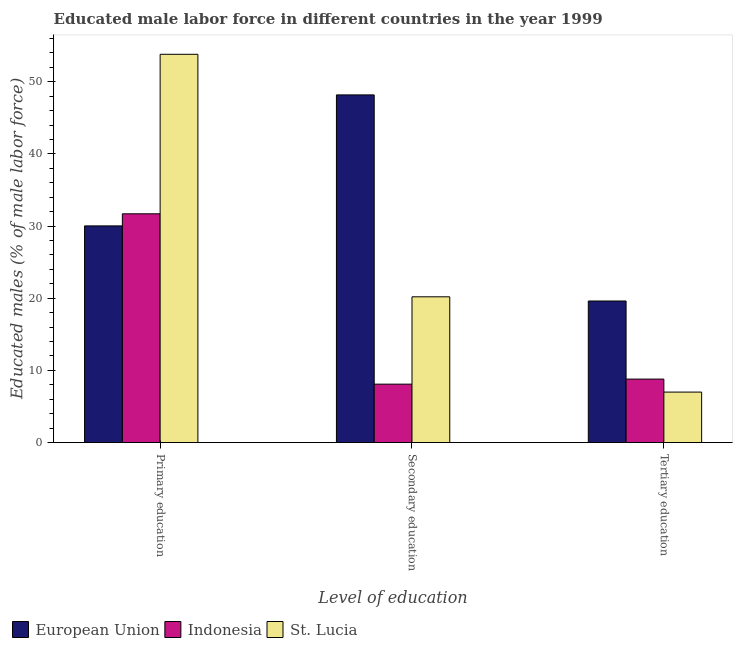How many different coloured bars are there?
Provide a short and direct response. 3. How many groups of bars are there?
Offer a very short reply. 3. Are the number of bars per tick equal to the number of legend labels?
Offer a very short reply. Yes. Are the number of bars on each tick of the X-axis equal?
Give a very brief answer. Yes. What is the label of the 2nd group of bars from the left?
Offer a very short reply. Secondary education. What is the percentage of male labor force who received primary education in European Union?
Keep it short and to the point. 30.02. Across all countries, what is the maximum percentage of male labor force who received secondary education?
Offer a terse response. 48.17. In which country was the percentage of male labor force who received primary education maximum?
Ensure brevity in your answer.  St. Lucia. In which country was the percentage of male labor force who received tertiary education minimum?
Give a very brief answer. St. Lucia. What is the total percentage of male labor force who received tertiary education in the graph?
Make the answer very short. 35.42. What is the difference between the percentage of male labor force who received tertiary education in European Union and that in Indonesia?
Give a very brief answer. 10.82. What is the difference between the percentage of male labor force who received tertiary education in St. Lucia and the percentage of male labor force who received secondary education in European Union?
Make the answer very short. -41.17. What is the average percentage of male labor force who received primary education per country?
Offer a very short reply. 38.51. What is the difference between the percentage of male labor force who received tertiary education and percentage of male labor force who received secondary education in European Union?
Your answer should be compact. -28.55. What is the ratio of the percentage of male labor force who received secondary education in Indonesia to that in European Union?
Provide a short and direct response. 0.17. What is the difference between the highest and the second highest percentage of male labor force who received secondary education?
Offer a very short reply. 27.97. What is the difference between the highest and the lowest percentage of male labor force who received secondary education?
Your response must be concise. 40.07. Is it the case that in every country, the sum of the percentage of male labor force who received primary education and percentage of male labor force who received secondary education is greater than the percentage of male labor force who received tertiary education?
Provide a short and direct response. Yes. Are all the bars in the graph horizontal?
Keep it short and to the point. No. How many countries are there in the graph?
Your response must be concise. 3. What is the difference between two consecutive major ticks on the Y-axis?
Provide a succinct answer. 10. How many legend labels are there?
Your answer should be very brief. 3. What is the title of the graph?
Your response must be concise. Educated male labor force in different countries in the year 1999. Does "Kyrgyz Republic" appear as one of the legend labels in the graph?
Provide a succinct answer. No. What is the label or title of the X-axis?
Your answer should be compact. Level of education. What is the label or title of the Y-axis?
Ensure brevity in your answer.  Educated males (% of male labor force). What is the Educated males (% of male labor force) of European Union in Primary education?
Ensure brevity in your answer.  30.02. What is the Educated males (% of male labor force) of Indonesia in Primary education?
Keep it short and to the point. 31.7. What is the Educated males (% of male labor force) in St. Lucia in Primary education?
Offer a terse response. 53.8. What is the Educated males (% of male labor force) in European Union in Secondary education?
Your answer should be very brief. 48.17. What is the Educated males (% of male labor force) of Indonesia in Secondary education?
Offer a very short reply. 8.1. What is the Educated males (% of male labor force) of St. Lucia in Secondary education?
Offer a terse response. 20.2. What is the Educated males (% of male labor force) in European Union in Tertiary education?
Ensure brevity in your answer.  19.62. What is the Educated males (% of male labor force) in Indonesia in Tertiary education?
Your answer should be very brief. 8.8. Across all Level of education, what is the maximum Educated males (% of male labor force) in European Union?
Offer a terse response. 48.17. Across all Level of education, what is the maximum Educated males (% of male labor force) of Indonesia?
Your answer should be very brief. 31.7. Across all Level of education, what is the maximum Educated males (% of male labor force) in St. Lucia?
Ensure brevity in your answer.  53.8. Across all Level of education, what is the minimum Educated males (% of male labor force) in European Union?
Ensure brevity in your answer.  19.62. Across all Level of education, what is the minimum Educated males (% of male labor force) of Indonesia?
Provide a succinct answer. 8.1. What is the total Educated males (% of male labor force) of European Union in the graph?
Your answer should be very brief. 97.82. What is the total Educated males (% of male labor force) in Indonesia in the graph?
Your answer should be very brief. 48.6. What is the difference between the Educated males (% of male labor force) of European Union in Primary education and that in Secondary education?
Give a very brief answer. -18.15. What is the difference between the Educated males (% of male labor force) in Indonesia in Primary education and that in Secondary education?
Keep it short and to the point. 23.6. What is the difference between the Educated males (% of male labor force) of St. Lucia in Primary education and that in Secondary education?
Ensure brevity in your answer.  33.6. What is the difference between the Educated males (% of male labor force) of European Union in Primary education and that in Tertiary education?
Provide a short and direct response. 10.41. What is the difference between the Educated males (% of male labor force) in Indonesia in Primary education and that in Tertiary education?
Offer a terse response. 22.9. What is the difference between the Educated males (% of male labor force) of St. Lucia in Primary education and that in Tertiary education?
Ensure brevity in your answer.  46.8. What is the difference between the Educated males (% of male labor force) in European Union in Secondary education and that in Tertiary education?
Offer a very short reply. 28.55. What is the difference between the Educated males (% of male labor force) in Indonesia in Secondary education and that in Tertiary education?
Your answer should be very brief. -0.7. What is the difference between the Educated males (% of male labor force) in European Union in Primary education and the Educated males (% of male labor force) in Indonesia in Secondary education?
Give a very brief answer. 21.92. What is the difference between the Educated males (% of male labor force) in European Union in Primary education and the Educated males (% of male labor force) in St. Lucia in Secondary education?
Give a very brief answer. 9.82. What is the difference between the Educated males (% of male labor force) of Indonesia in Primary education and the Educated males (% of male labor force) of St. Lucia in Secondary education?
Make the answer very short. 11.5. What is the difference between the Educated males (% of male labor force) of European Union in Primary education and the Educated males (% of male labor force) of Indonesia in Tertiary education?
Provide a short and direct response. 21.22. What is the difference between the Educated males (% of male labor force) of European Union in Primary education and the Educated males (% of male labor force) of St. Lucia in Tertiary education?
Your answer should be compact. 23.02. What is the difference between the Educated males (% of male labor force) in Indonesia in Primary education and the Educated males (% of male labor force) in St. Lucia in Tertiary education?
Provide a succinct answer. 24.7. What is the difference between the Educated males (% of male labor force) of European Union in Secondary education and the Educated males (% of male labor force) of Indonesia in Tertiary education?
Offer a terse response. 39.37. What is the difference between the Educated males (% of male labor force) of European Union in Secondary education and the Educated males (% of male labor force) of St. Lucia in Tertiary education?
Your answer should be very brief. 41.17. What is the average Educated males (% of male labor force) in European Union per Level of education?
Make the answer very short. 32.61. What is the average Educated males (% of male labor force) in Indonesia per Level of education?
Offer a terse response. 16.2. What is the average Educated males (% of male labor force) in St. Lucia per Level of education?
Offer a terse response. 27. What is the difference between the Educated males (% of male labor force) of European Union and Educated males (% of male labor force) of Indonesia in Primary education?
Keep it short and to the point. -1.68. What is the difference between the Educated males (% of male labor force) in European Union and Educated males (% of male labor force) in St. Lucia in Primary education?
Ensure brevity in your answer.  -23.78. What is the difference between the Educated males (% of male labor force) of Indonesia and Educated males (% of male labor force) of St. Lucia in Primary education?
Your answer should be very brief. -22.1. What is the difference between the Educated males (% of male labor force) of European Union and Educated males (% of male labor force) of Indonesia in Secondary education?
Provide a short and direct response. 40.07. What is the difference between the Educated males (% of male labor force) of European Union and Educated males (% of male labor force) of St. Lucia in Secondary education?
Ensure brevity in your answer.  27.97. What is the difference between the Educated males (% of male labor force) in European Union and Educated males (% of male labor force) in Indonesia in Tertiary education?
Your answer should be very brief. 10.82. What is the difference between the Educated males (% of male labor force) in European Union and Educated males (% of male labor force) in St. Lucia in Tertiary education?
Offer a terse response. 12.62. What is the difference between the Educated males (% of male labor force) of Indonesia and Educated males (% of male labor force) of St. Lucia in Tertiary education?
Ensure brevity in your answer.  1.8. What is the ratio of the Educated males (% of male labor force) of European Union in Primary education to that in Secondary education?
Your answer should be compact. 0.62. What is the ratio of the Educated males (% of male labor force) in Indonesia in Primary education to that in Secondary education?
Keep it short and to the point. 3.91. What is the ratio of the Educated males (% of male labor force) in St. Lucia in Primary education to that in Secondary education?
Give a very brief answer. 2.66. What is the ratio of the Educated males (% of male labor force) in European Union in Primary education to that in Tertiary education?
Your answer should be very brief. 1.53. What is the ratio of the Educated males (% of male labor force) of Indonesia in Primary education to that in Tertiary education?
Your answer should be very brief. 3.6. What is the ratio of the Educated males (% of male labor force) in St. Lucia in Primary education to that in Tertiary education?
Provide a short and direct response. 7.69. What is the ratio of the Educated males (% of male labor force) of European Union in Secondary education to that in Tertiary education?
Make the answer very short. 2.46. What is the ratio of the Educated males (% of male labor force) in Indonesia in Secondary education to that in Tertiary education?
Offer a terse response. 0.92. What is the ratio of the Educated males (% of male labor force) in St. Lucia in Secondary education to that in Tertiary education?
Provide a short and direct response. 2.89. What is the difference between the highest and the second highest Educated males (% of male labor force) of European Union?
Offer a very short reply. 18.15. What is the difference between the highest and the second highest Educated males (% of male labor force) in Indonesia?
Give a very brief answer. 22.9. What is the difference between the highest and the second highest Educated males (% of male labor force) in St. Lucia?
Offer a very short reply. 33.6. What is the difference between the highest and the lowest Educated males (% of male labor force) in European Union?
Make the answer very short. 28.55. What is the difference between the highest and the lowest Educated males (% of male labor force) of Indonesia?
Make the answer very short. 23.6. What is the difference between the highest and the lowest Educated males (% of male labor force) of St. Lucia?
Ensure brevity in your answer.  46.8. 